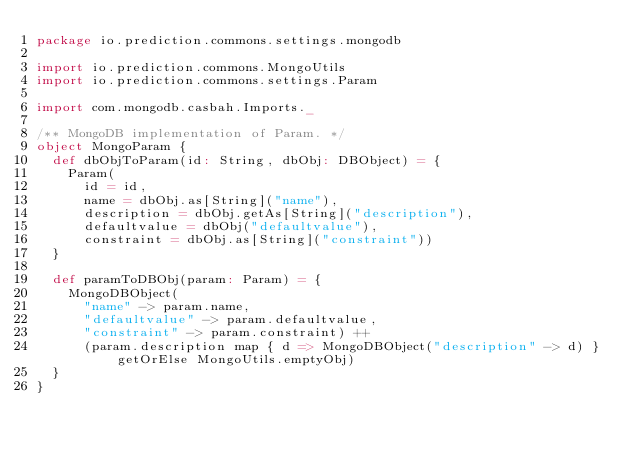<code> <loc_0><loc_0><loc_500><loc_500><_Scala_>package io.prediction.commons.settings.mongodb

import io.prediction.commons.MongoUtils
import io.prediction.commons.settings.Param

import com.mongodb.casbah.Imports._

/** MongoDB implementation of Param. */
object MongoParam {
  def dbObjToParam(id: String, dbObj: DBObject) = {
    Param(
      id = id,
      name = dbObj.as[String]("name"),
      description = dbObj.getAs[String]("description"),
      defaultvalue = dbObj("defaultvalue"),
      constraint = dbObj.as[String]("constraint"))
  }

  def paramToDBObj(param: Param) = {
    MongoDBObject(
      "name" -> param.name,
      "defaultvalue" -> param.defaultvalue,
      "constraint" -> param.constraint) ++
      (param.description map { d => MongoDBObject("description" -> d) } getOrElse MongoUtils.emptyObj)
  }
}
</code> 